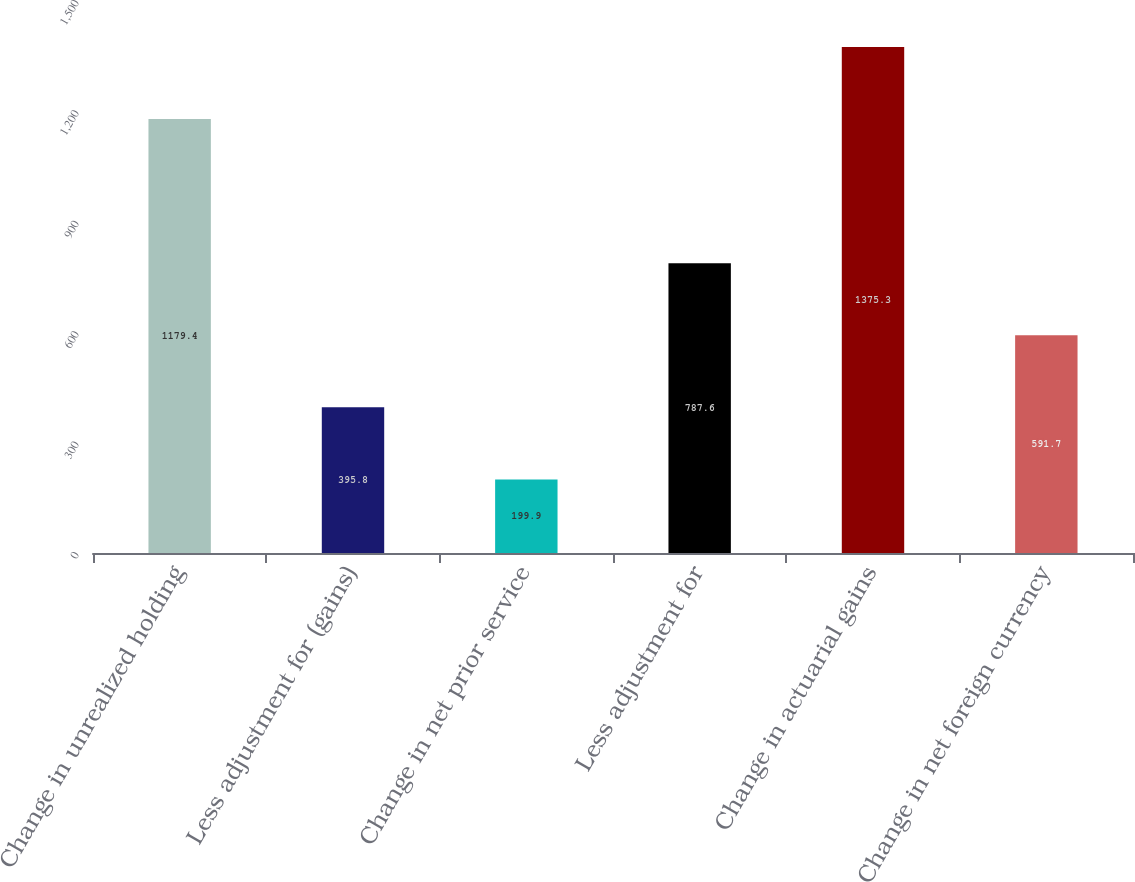Convert chart. <chart><loc_0><loc_0><loc_500><loc_500><bar_chart><fcel>Change in unrealized holding<fcel>Less adjustment for (gains)<fcel>Change in net prior service<fcel>Less adjustment for<fcel>Change in actuarial gains<fcel>Change in net foreign currency<nl><fcel>1179.4<fcel>395.8<fcel>199.9<fcel>787.6<fcel>1375.3<fcel>591.7<nl></chart> 